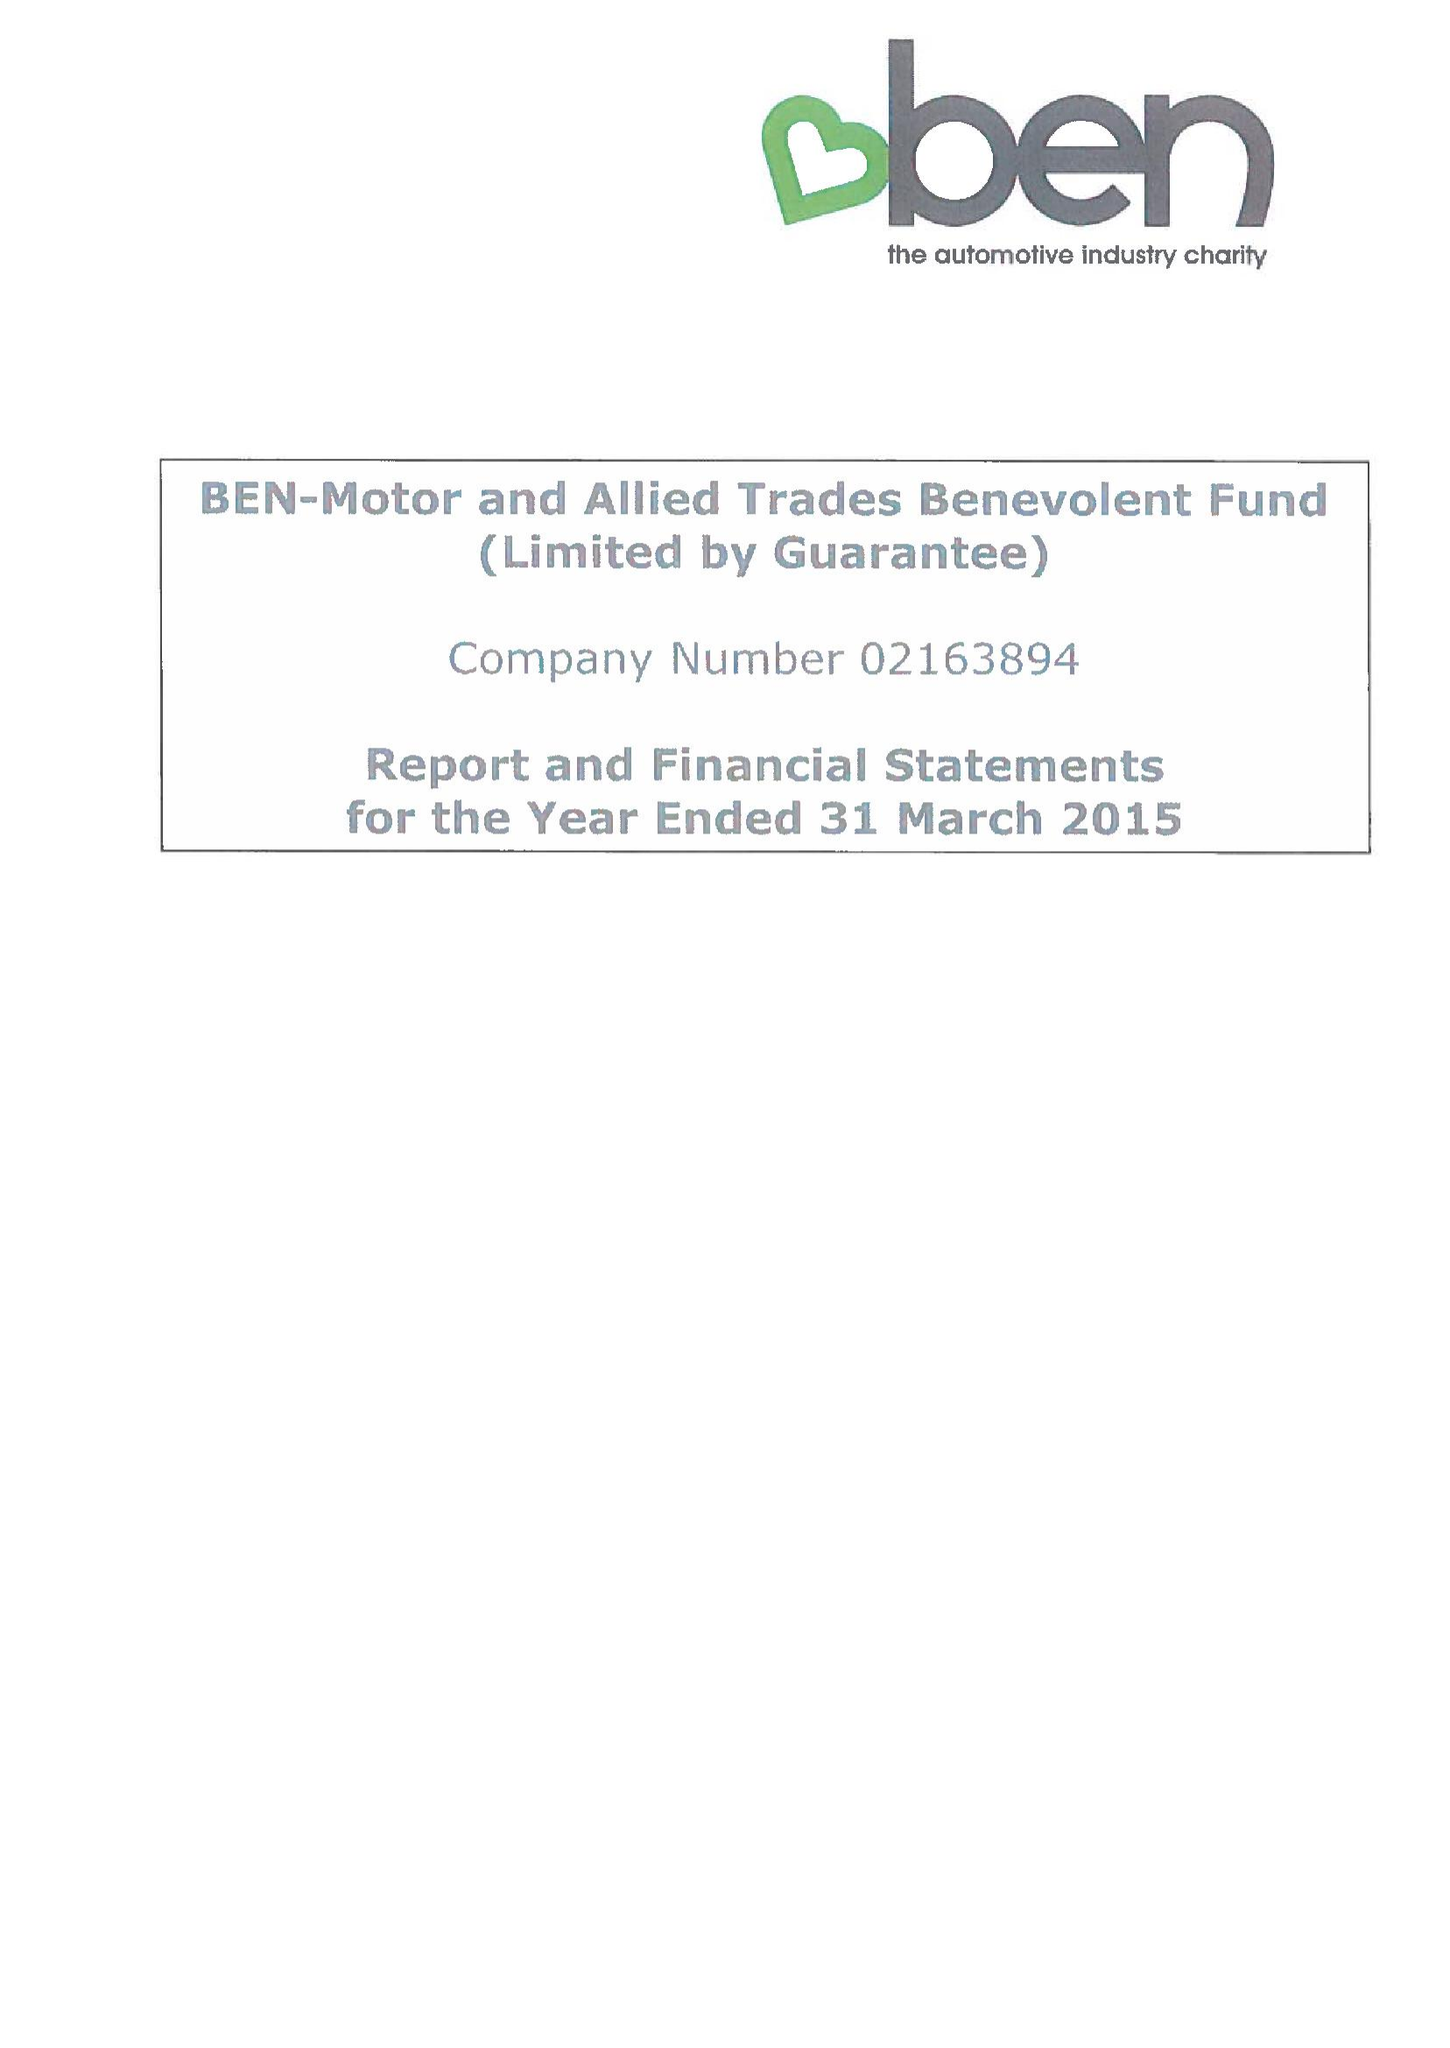What is the value for the income_annually_in_british_pounds?
Answer the question using a single word or phrase. 13461620.00 